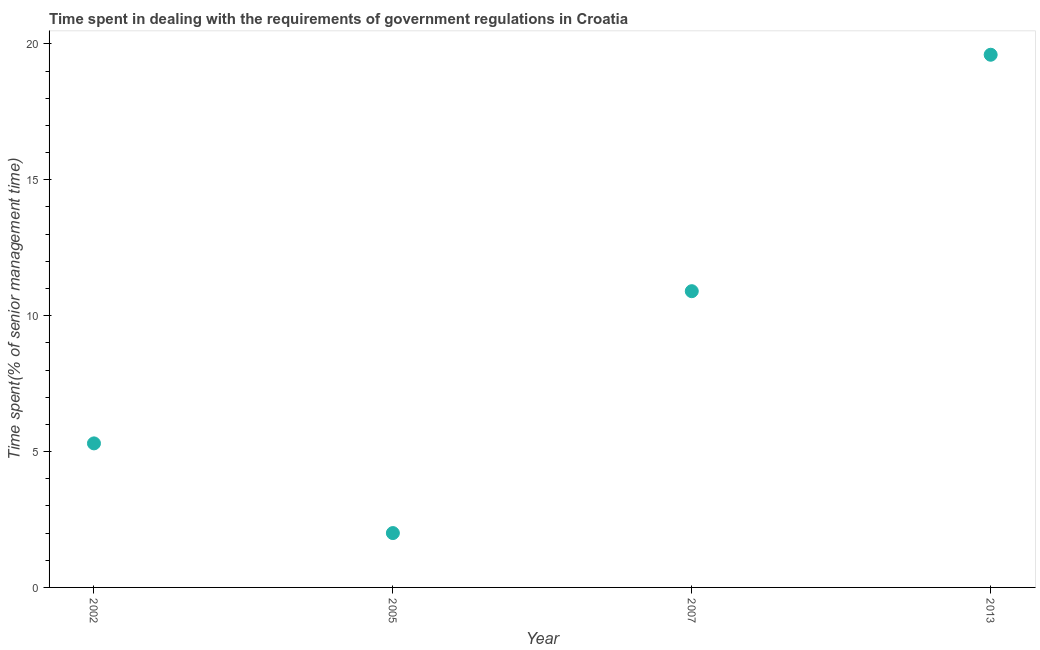What is the time spent in dealing with government regulations in 2007?
Your response must be concise. 10.9. Across all years, what is the maximum time spent in dealing with government regulations?
Your answer should be very brief. 19.6. In which year was the time spent in dealing with government regulations minimum?
Keep it short and to the point. 2005. What is the sum of the time spent in dealing with government regulations?
Offer a very short reply. 37.8. What is the difference between the time spent in dealing with government regulations in 2002 and 2013?
Your response must be concise. -14.3. What is the average time spent in dealing with government regulations per year?
Keep it short and to the point. 9.45. What is the median time spent in dealing with government regulations?
Offer a terse response. 8.1. In how many years, is the time spent in dealing with government regulations greater than 10 %?
Your answer should be very brief. 2. Do a majority of the years between 2002 and 2005 (inclusive) have time spent in dealing with government regulations greater than 8 %?
Provide a short and direct response. No. What is the ratio of the time spent in dealing with government regulations in 2002 to that in 2005?
Ensure brevity in your answer.  2.65. Is the time spent in dealing with government regulations in 2007 less than that in 2013?
Offer a very short reply. Yes. Is the difference between the time spent in dealing with government regulations in 2002 and 2007 greater than the difference between any two years?
Offer a terse response. No. What is the difference between the highest and the second highest time spent in dealing with government regulations?
Keep it short and to the point. 8.7. Is the sum of the time spent in dealing with government regulations in 2005 and 2013 greater than the maximum time spent in dealing with government regulations across all years?
Provide a short and direct response. Yes. How many dotlines are there?
Your response must be concise. 1. How many years are there in the graph?
Offer a very short reply. 4. Are the values on the major ticks of Y-axis written in scientific E-notation?
Keep it short and to the point. No. What is the title of the graph?
Provide a short and direct response. Time spent in dealing with the requirements of government regulations in Croatia. What is the label or title of the Y-axis?
Offer a terse response. Time spent(% of senior management time). What is the Time spent(% of senior management time) in 2002?
Your response must be concise. 5.3. What is the Time spent(% of senior management time) in 2013?
Keep it short and to the point. 19.6. What is the difference between the Time spent(% of senior management time) in 2002 and 2013?
Your response must be concise. -14.3. What is the difference between the Time spent(% of senior management time) in 2005 and 2013?
Provide a succinct answer. -17.6. What is the difference between the Time spent(% of senior management time) in 2007 and 2013?
Provide a succinct answer. -8.7. What is the ratio of the Time spent(% of senior management time) in 2002 to that in 2005?
Keep it short and to the point. 2.65. What is the ratio of the Time spent(% of senior management time) in 2002 to that in 2007?
Your answer should be compact. 0.49. What is the ratio of the Time spent(% of senior management time) in 2002 to that in 2013?
Ensure brevity in your answer.  0.27. What is the ratio of the Time spent(% of senior management time) in 2005 to that in 2007?
Your answer should be compact. 0.18. What is the ratio of the Time spent(% of senior management time) in 2005 to that in 2013?
Your response must be concise. 0.1. What is the ratio of the Time spent(% of senior management time) in 2007 to that in 2013?
Offer a very short reply. 0.56. 